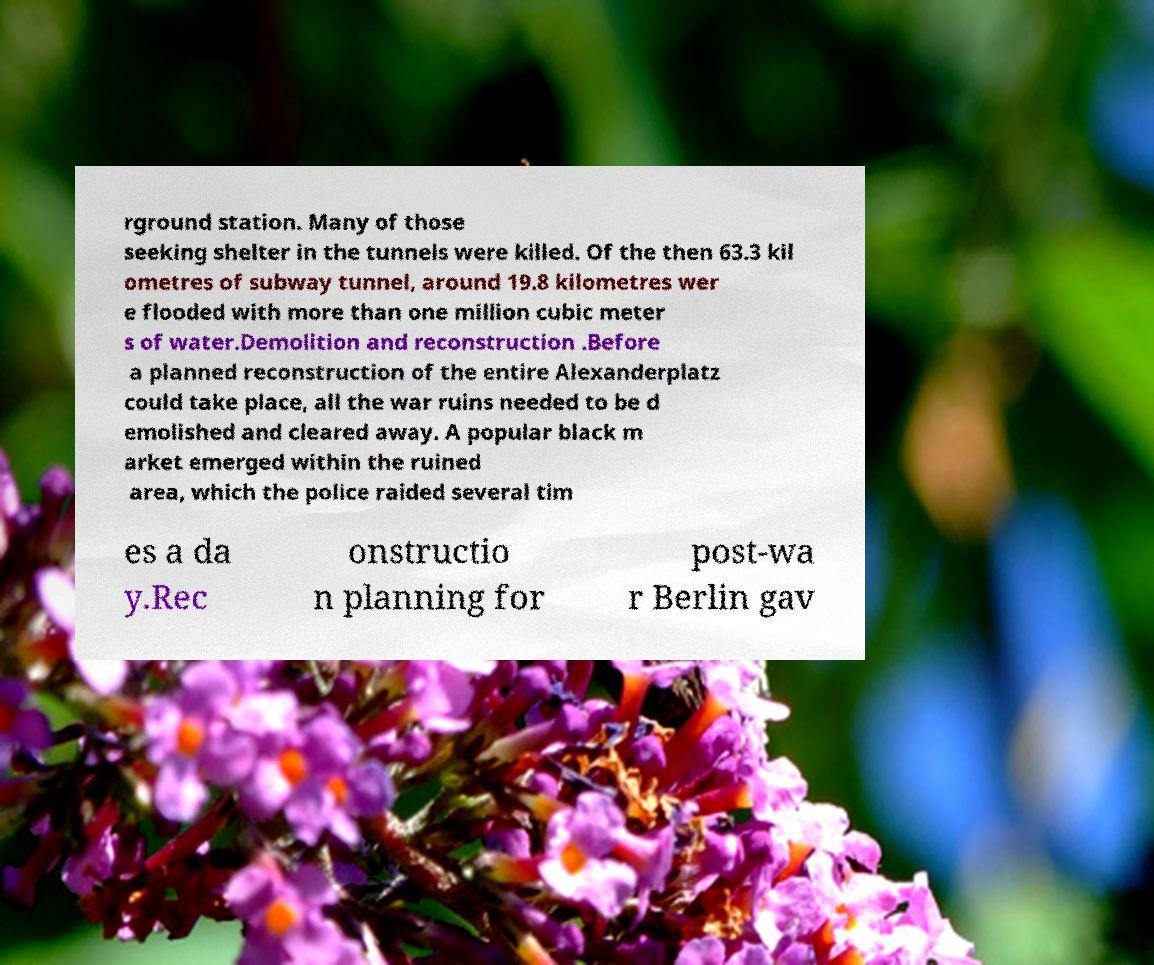Can you accurately transcribe the text from the provided image for me? rground station. Many of those seeking shelter in the tunnels were killed. Of the then 63.3 kil ometres of subway tunnel, around 19.8 kilometres wer e flooded with more than one million cubic meter s of water.Demolition and reconstruction .Before a planned reconstruction of the entire Alexanderplatz could take place, all the war ruins needed to be d emolished and cleared away. A popular black m arket emerged within the ruined area, which the police raided several tim es a da y.Rec onstructio n planning for post-wa r Berlin gav 